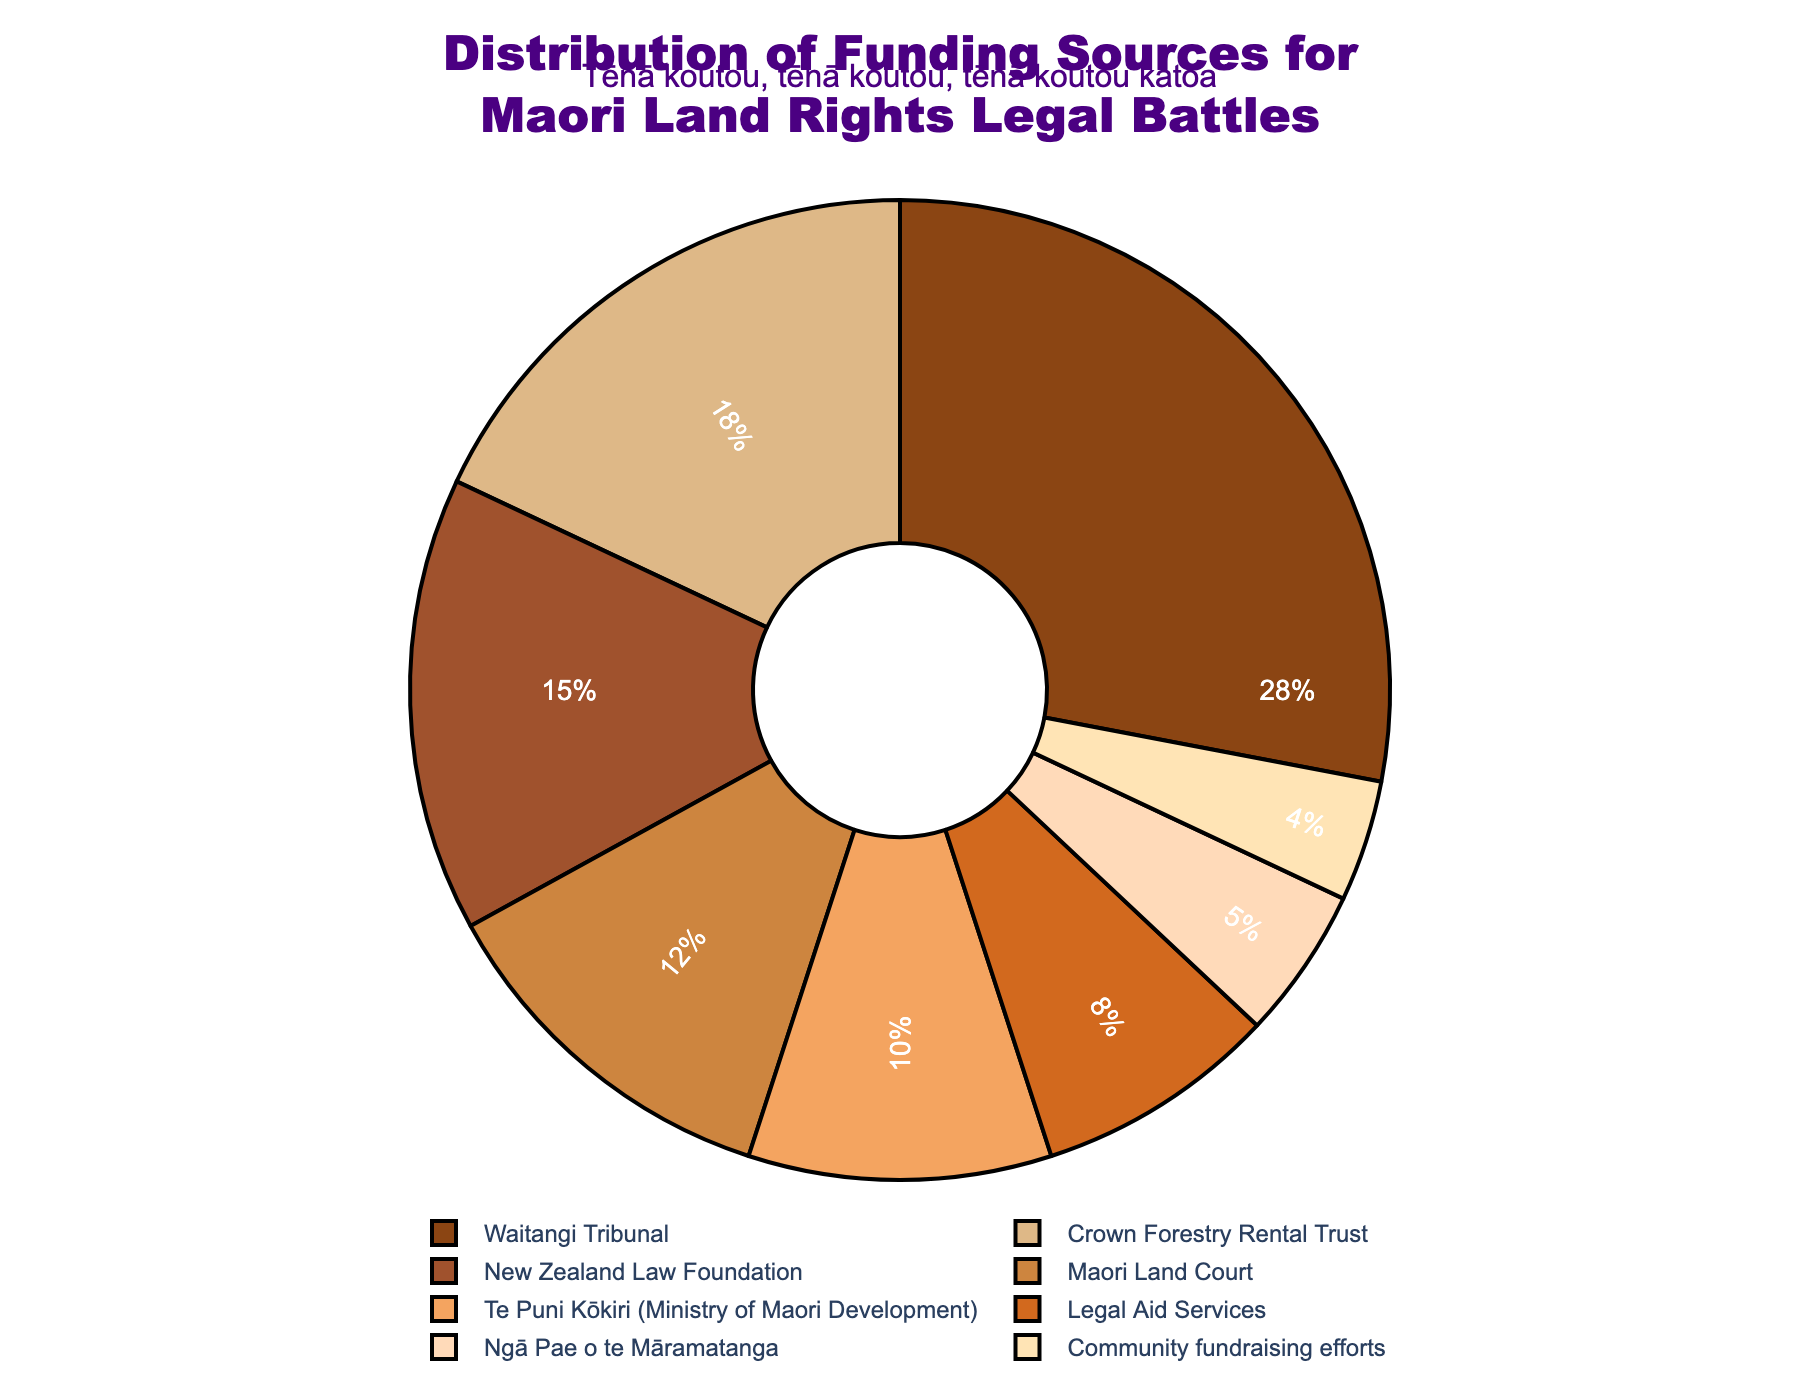Which funding source contributes the most to Maori land rights legal battles? By looking at the figure, the largest segment is the one representing the Waitangi Tribunal.
Answer: Waitangi Tribunal Which two funding sources provide less than 10% each of the total funding? Observing the pie chart, Legal Aid Services and Community fundraising efforts each contribute 8% and 4% respectively, which are both less than 10%.
Answer: Legal Aid Services, Community fundraising efforts How much more does the New Zealand Law Foundation contribute compared to Legal Aid Services? The New Zealand Law Foundation contributes 15%, while Legal Aid Services contribute 8%. The difference is 15% - 8% = 7%.
Answer: 7% What is the combined contribution of Te Puni Kōkiri and Community fundraising efforts? The contributions of Te Puni Kōkiri and Community fundraising efforts are 10% and 4%, respectively. Adding these gives 10% + 4% = 14%.
Answer: 14% Which funding sources have their contributions represented in visual elements using shades of brown? The visual elements for Waitangi Tribunal, New Zealand Law Foundation, Maori Land Court, and Crown Forestry Rental Trust are represented with shades of brown.
Answer: Waitangi Tribunal, New Zealand Law Foundation, Maori Land Court, Crown Forestry Rental Trust Is the contribution from the Maori Land Court more or less than half of the contribution from the Waitangi Tribunal? The Maori Land Court contributes 12%, while the Waitangi Tribunal contributes 28%. Half of the Waitangi Tribunal's contribution is 28% / 2 = 14%. Since 12% is less than 14%, the Maori Land Court's contribution is less than half.
Answer: Less What funding sources contribute between 10% and 20%? According to the pie chart, Crown Forestry Rental Trust (18%), Te Puni Kōkiri (10%), and Maori Land Court (12%) all have contributions within this range.
Answer: Crown Forestry Rental Trust, Te Puni Kōkiri, Maori Land Court Which funding source contributes the least? The smallest segment in the pie chart represents Community fundraising efforts, contributing 4%.
Answer: Community fundraising efforts How does the contribution of Ngā Pae o te Māramatanga compare to the combined contribution of Te Puni Kōkiri and Legal Aid Services? Ngā Pae o te Māramatanga contributes 5%, while the combined contribution of Te Puni Kōkiri (10%) and Legal Aid Services (8%) is 10% + 8% = 18%. Ngā Pae o te Māramatanga's contribution is less.
Answer: Less 